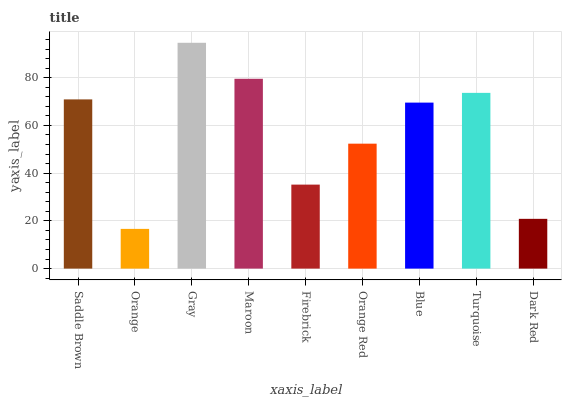Is Gray the minimum?
Answer yes or no. No. Is Orange the maximum?
Answer yes or no. No. Is Gray greater than Orange?
Answer yes or no. Yes. Is Orange less than Gray?
Answer yes or no. Yes. Is Orange greater than Gray?
Answer yes or no. No. Is Gray less than Orange?
Answer yes or no. No. Is Blue the high median?
Answer yes or no. Yes. Is Blue the low median?
Answer yes or no. Yes. Is Turquoise the high median?
Answer yes or no. No. Is Dark Red the low median?
Answer yes or no. No. 